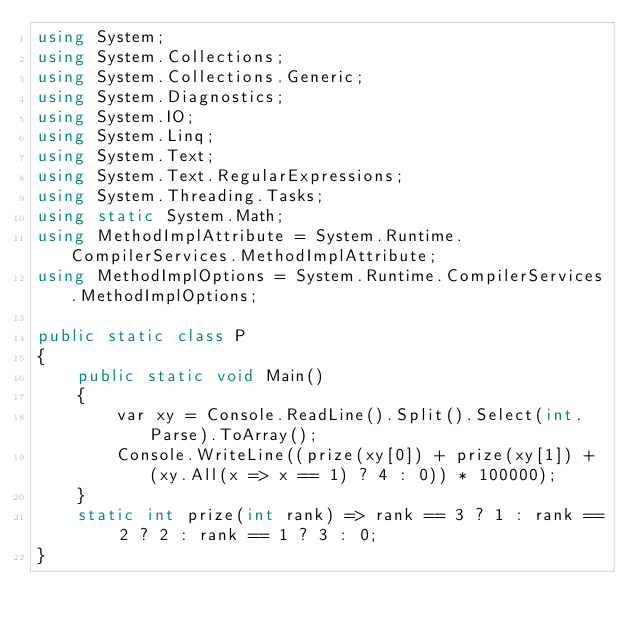<code> <loc_0><loc_0><loc_500><loc_500><_C#_>using System;
using System.Collections;
using System.Collections.Generic;
using System.Diagnostics;
using System.IO;
using System.Linq;
using System.Text;
using System.Text.RegularExpressions;
using System.Threading.Tasks;
using static System.Math;
using MethodImplAttribute = System.Runtime.CompilerServices.MethodImplAttribute;
using MethodImplOptions = System.Runtime.CompilerServices.MethodImplOptions;

public static class P
{
    public static void Main()
    {
        var xy = Console.ReadLine().Split().Select(int.Parse).ToArray();
        Console.WriteLine((prize(xy[0]) + prize(xy[1]) + (xy.All(x => x == 1) ? 4 : 0)) * 100000);
    }
    static int prize(int rank) => rank == 3 ? 1 : rank == 2 ? 2 : rank == 1 ? 3 : 0;
}
</code> 